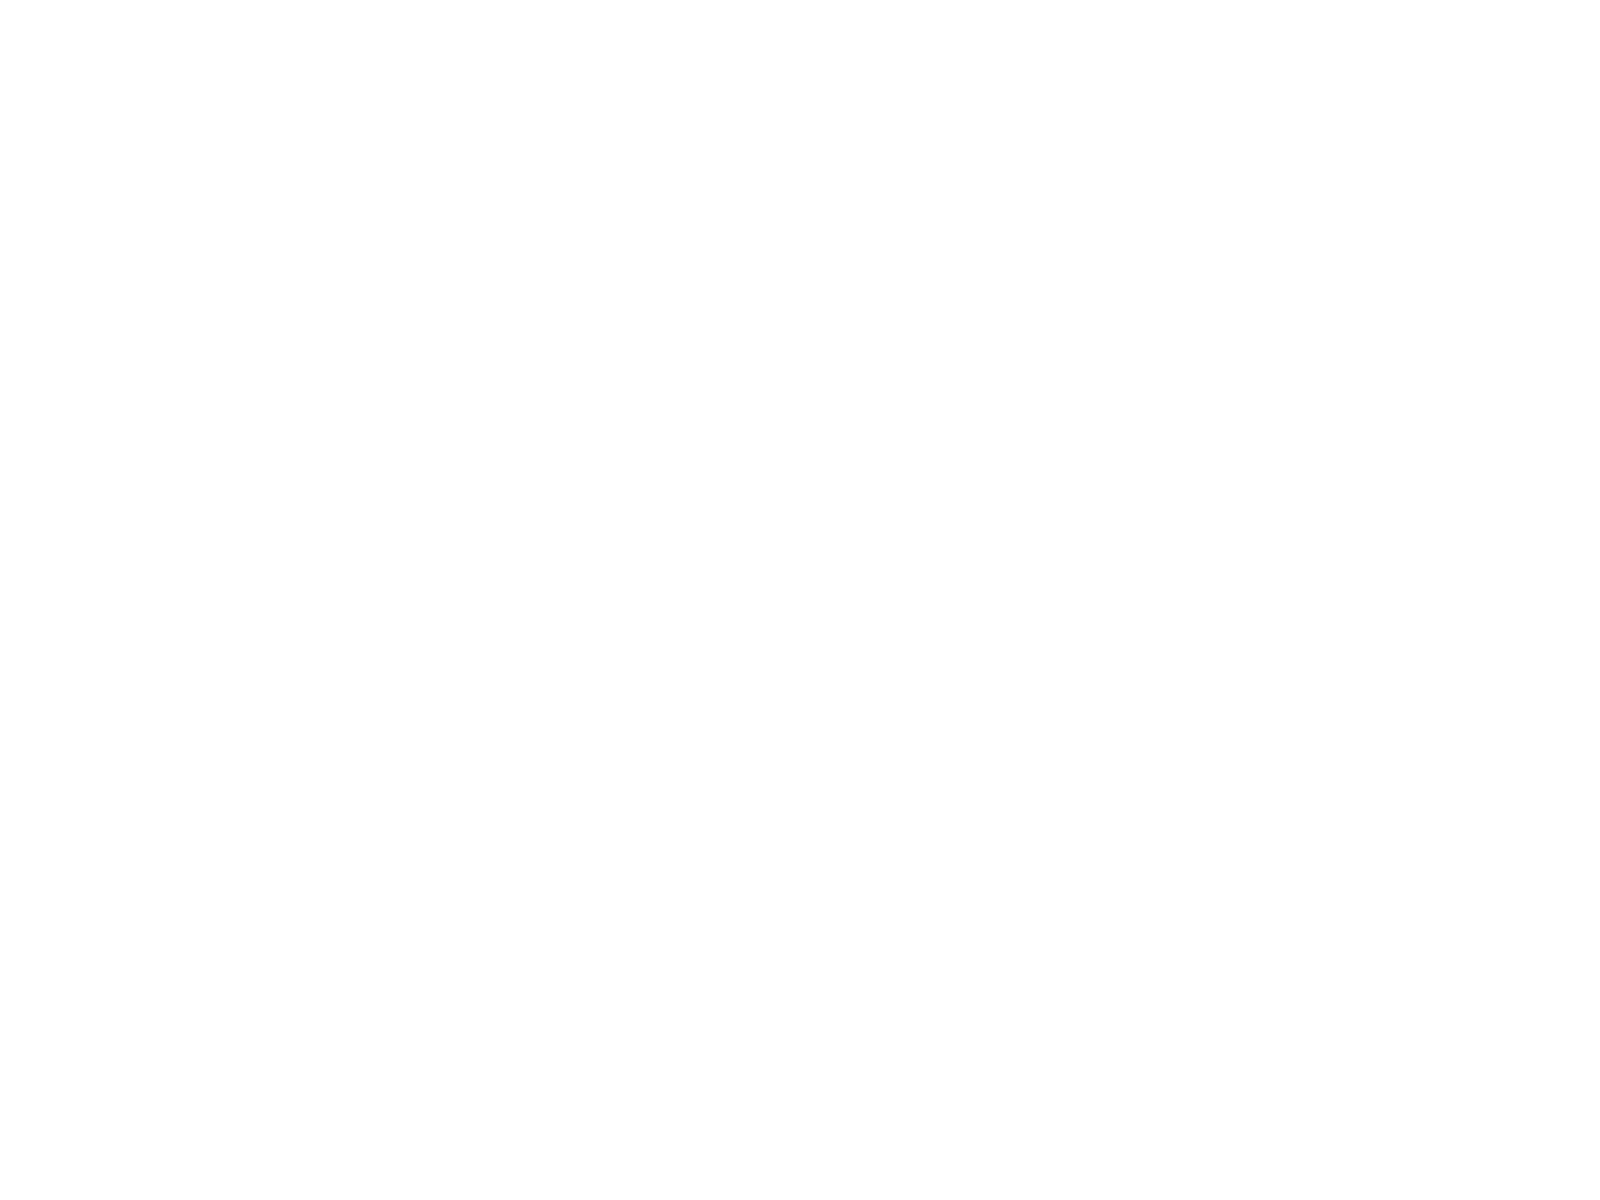Convert chart. <chart><loc_0><loc_0><loc_500><loc_500><pie_chart><fcel>1985-2011<fcel>1984-2011<fcel>2000-2011<nl><fcel>30.38%<fcel>34.18%<fcel>35.44%<nl></chart> 